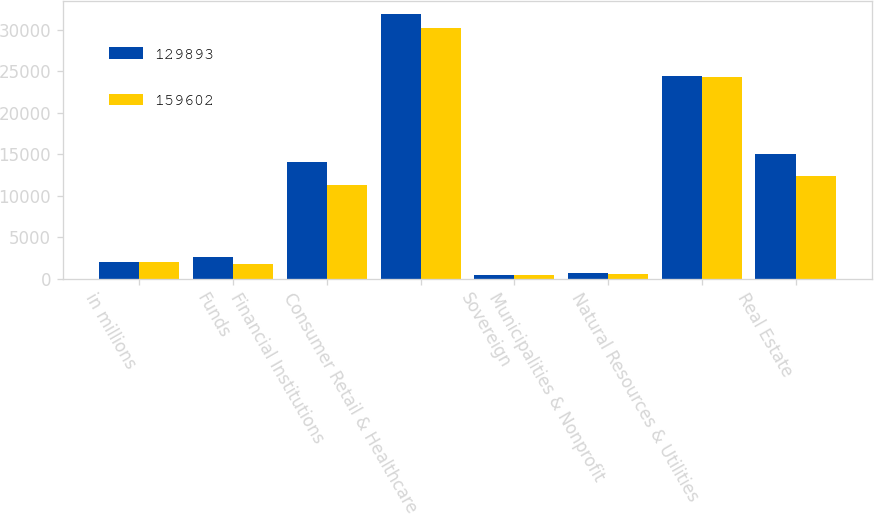Convert chart to OTSL. <chart><loc_0><loc_0><loc_500><loc_500><stacked_bar_chart><ecel><fcel>in millions<fcel>Funds<fcel>Financial Institutions<fcel>Consumer Retail & Healthcare<fcel>Sovereign<fcel>Municipalities & Nonprofit<fcel>Natural Resources & Utilities<fcel>Real Estate<nl><fcel>129893<fcel>2015<fcel>2595<fcel>14063<fcel>31944<fcel>419<fcel>628<fcel>24476<fcel>15045<nl><fcel>159602<fcel>2014<fcel>1706<fcel>11316<fcel>30216<fcel>450<fcel>541<fcel>24275<fcel>12366<nl></chart> 